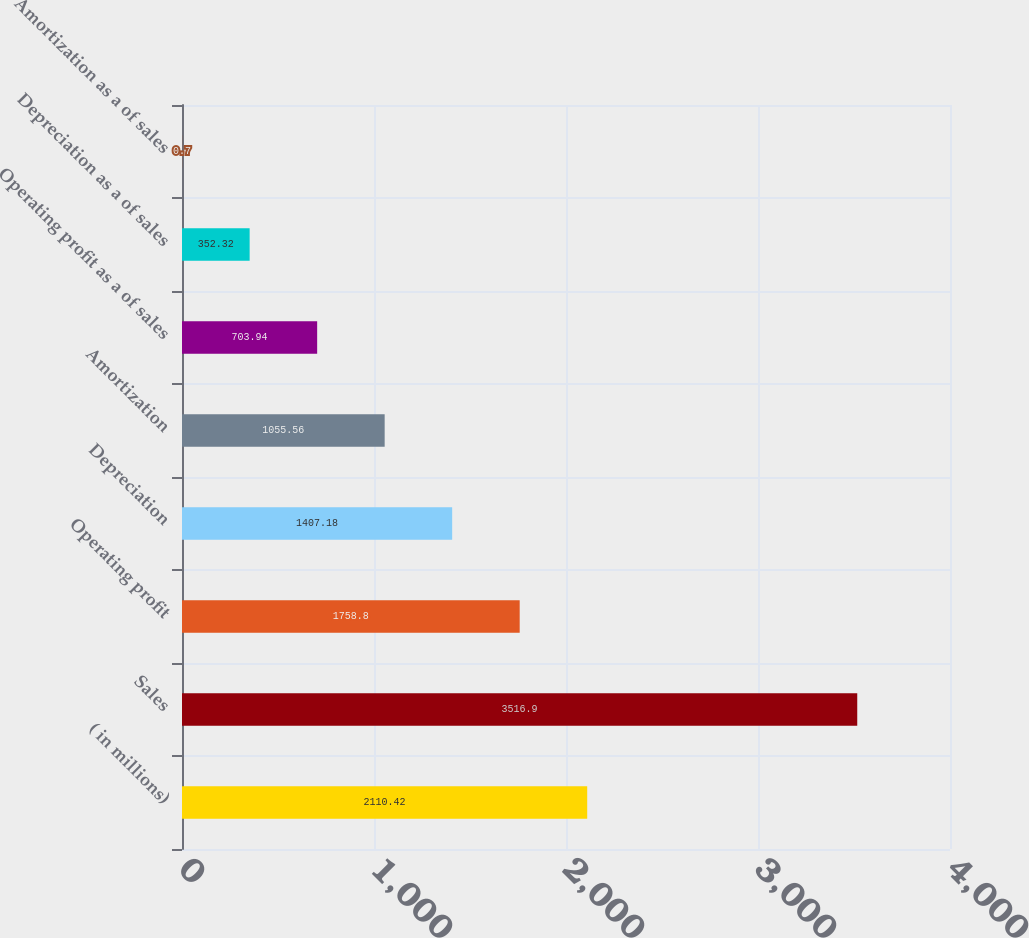<chart> <loc_0><loc_0><loc_500><loc_500><bar_chart><fcel>( in millions)<fcel>Sales<fcel>Operating profit<fcel>Depreciation<fcel>Amortization<fcel>Operating profit as a of sales<fcel>Depreciation as a of sales<fcel>Amortization as a of sales<nl><fcel>2110.42<fcel>3516.9<fcel>1758.8<fcel>1407.18<fcel>1055.56<fcel>703.94<fcel>352.32<fcel>0.7<nl></chart> 